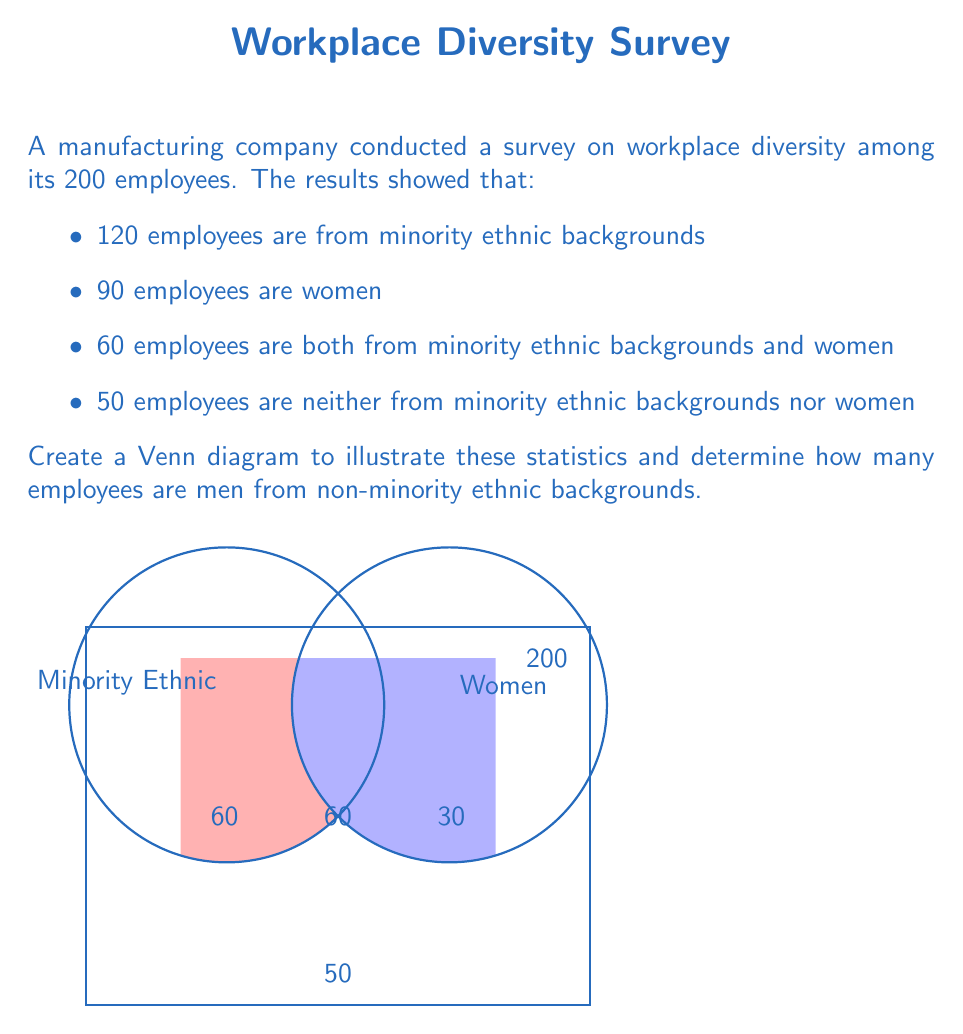Show me your answer to this math problem. Let's approach this step-by-step:

1) First, let's identify our sets:
   A: Employees from minority ethnic backgrounds
   B: Women employees

2) We're given the following information:
   - Total employees: 200
   - |A| (Minority ethnic): 120
   - |B| (Women): 90
   - |A ∩ B| (Both minority ethnic and women): 60
   - Neither minority ethnic nor women: 50

3) Let's fill in the Venn diagram:
   - A ∩ B (intersection): 60
   - A only: 120 - 60 = 60
   - B only: 90 - 60 = 30
   - Neither: 50

4) To check our work, let's sum all regions:
   60 + 60 + 30 + 50 = 200 (correct)

5) Now, to find men from non-minority ethnic backgrounds:
   - These are employees who are neither from minority ethnic backgrounds nor women
   - This is the region outside both circles: 50

Therefore, there are 50 men from non-minority ethnic backgrounds.
Answer: 50 